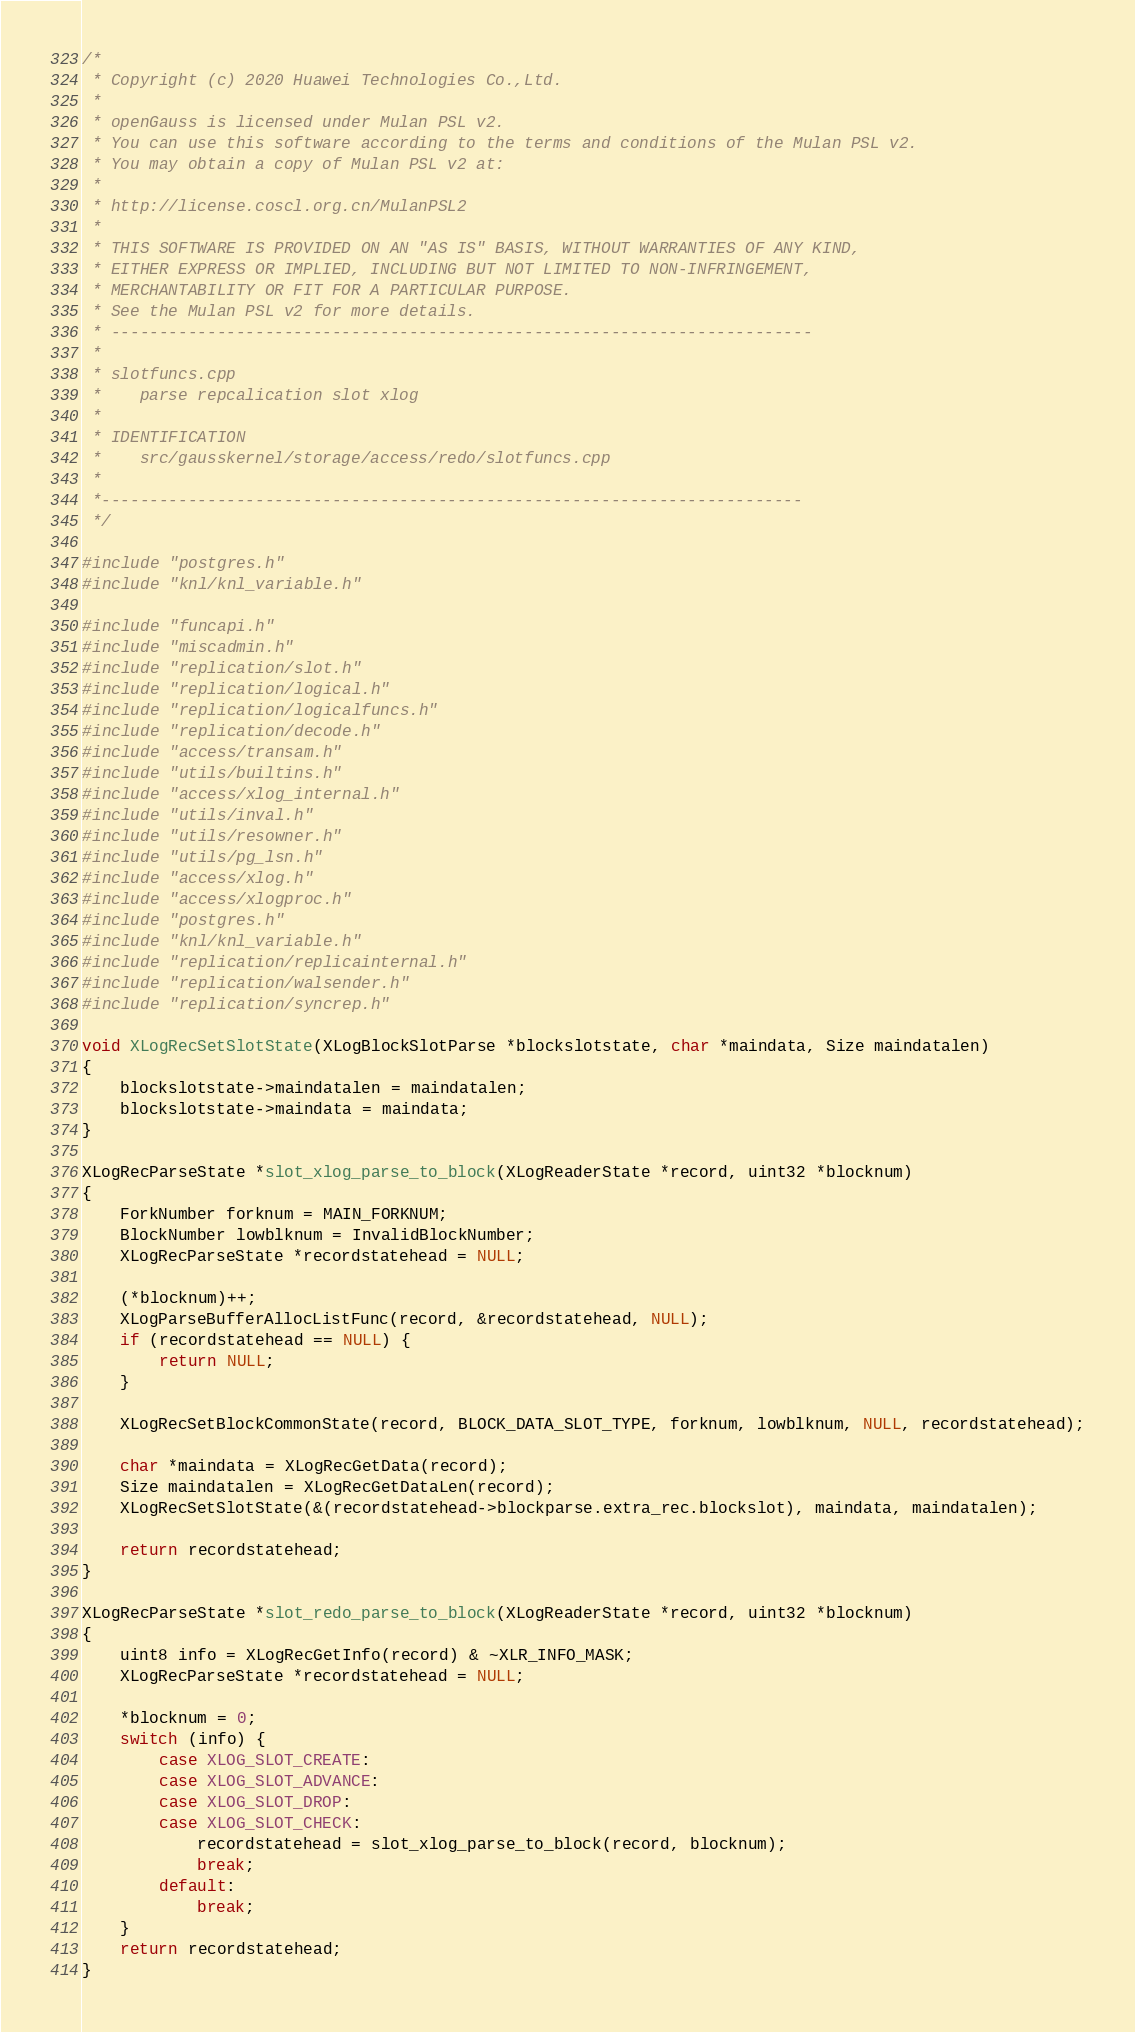<code> <loc_0><loc_0><loc_500><loc_500><_C++_>/*
 * Copyright (c) 2020 Huawei Technologies Co.,Ltd.
 *
 * openGauss is licensed under Mulan PSL v2.
 * You can use this software according to the terms and conditions of the Mulan PSL v2.
 * You may obtain a copy of Mulan PSL v2 at:
 *
 * http://license.coscl.org.cn/MulanPSL2
 *
 * THIS SOFTWARE IS PROVIDED ON AN "AS IS" BASIS, WITHOUT WARRANTIES OF ANY KIND,
 * EITHER EXPRESS OR IMPLIED, INCLUDING BUT NOT LIMITED TO NON-INFRINGEMENT,
 * MERCHANTABILITY OR FIT FOR A PARTICULAR PURPOSE.
 * See the Mulan PSL v2 for more details.
 * -------------------------------------------------------------------------
 *
 * slotfuncs.cpp
 *    parse repcalication slot xlog
 *
 * IDENTIFICATION
 *    src/gausskernel/storage/access/redo/slotfuncs.cpp
 *
 *-------------------------------------------------------------------------
 */

#include "postgres.h"
#include "knl/knl_variable.h"

#include "funcapi.h"
#include "miscadmin.h"
#include "replication/slot.h"
#include "replication/logical.h"
#include "replication/logicalfuncs.h"
#include "replication/decode.h"
#include "access/transam.h"
#include "utils/builtins.h"
#include "access/xlog_internal.h"
#include "utils/inval.h"
#include "utils/resowner.h"
#include "utils/pg_lsn.h"
#include "access/xlog.h"
#include "access/xlogproc.h"
#include "postgres.h"
#include "knl/knl_variable.h"
#include "replication/replicainternal.h"
#include "replication/walsender.h"
#include "replication/syncrep.h"

void XLogRecSetSlotState(XLogBlockSlotParse *blockslotstate, char *maindata, Size maindatalen)
{
    blockslotstate->maindatalen = maindatalen;
    blockslotstate->maindata = maindata;
}

XLogRecParseState *slot_xlog_parse_to_block(XLogReaderState *record, uint32 *blocknum)
{
    ForkNumber forknum = MAIN_FORKNUM;
    BlockNumber lowblknum = InvalidBlockNumber;
    XLogRecParseState *recordstatehead = NULL;

    (*blocknum)++;
    XLogParseBufferAllocListFunc(record, &recordstatehead, NULL);
    if (recordstatehead == NULL) {
        return NULL;
    }

    XLogRecSetBlockCommonState(record, BLOCK_DATA_SLOT_TYPE, forknum, lowblknum, NULL, recordstatehead);

    char *maindata = XLogRecGetData(record);
    Size maindatalen = XLogRecGetDataLen(record);
    XLogRecSetSlotState(&(recordstatehead->blockparse.extra_rec.blockslot), maindata, maindatalen);

    return recordstatehead;
}

XLogRecParseState *slot_redo_parse_to_block(XLogReaderState *record, uint32 *blocknum)
{
    uint8 info = XLogRecGetInfo(record) & ~XLR_INFO_MASK;
    XLogRecParseState *recordstatehead = NULL;

    *blocknum = 0;
    switch (info) {
        case XLOG_SLOT_CREATE:
        case XLOG_SLOT_ADVANCE:
        case XLOG_SLOT_DROP:
        case XLOG_SLOT_CHECK:
            recordstatehead = slot_xlog_parse_to_block(record, blocknum);
            break;
        default:
            break;
    }
    return recordstatehead;
}
</code> 